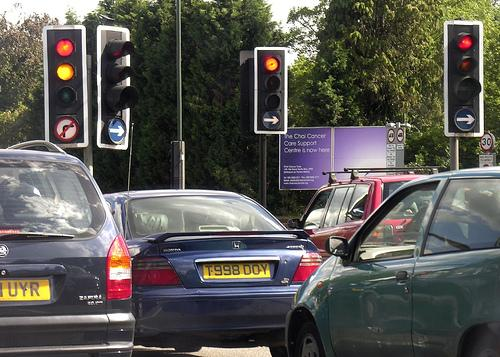Identify three types of signs in the image and describe their appearance. 3. No right turn sign List the colors of the different objects in the image. Red, yellow, blue, white, black, silver, green, orangered, purple What types of trees can you see in the image and what is their condition? Tree branches with green leafs and tall trees near a street intersection, both in a healthy condition. What color is the license plate on the blue car and what might it be made of? The license plate is yellow with black letters and may likely be made of metal or plastic. Describe the condition of the traffic light in the image. The traffic light shows red and yellow lights lit, indicating that vehicles should stop and be prepared for a change in traffic signals. In one sentence, what significant event is happening in the image? Four vehicles are waiting at a traffic intersection with red and yellow traffic lights. Which object in the image is related to supporting cancer patients? A purple sign for a cancer support center with white writing. What key features can you observe on the rear end of the blue car? A yellow license plate with black letters, tail light with orangered and white glass, and silver logo. What are the two main types of objects visible in this scene? Vehicles and traffic signals Is the front side of a green truck visible at X:326 Y:175 Width:89 Height:89? The instruction refers to a nonexistent object in the image, as there is no front side of a green truck in the given coordinates. Can you locate a white speed limit sign at X:478 Y:130 Width:20 Height:20, indicating the speed limit is 50 mph? The instruction is misleading as there is a speed limit sign at these coordinates, but it is not specified what speed is indicated on it. Is there a traffic light with a green arrow pointing upwards at X:254 Y:45 Width:34 Height:34? The instruction is misleading because the traffic light at the given coordinates has an arrow pointing right, not upwards, and there is no mention of the color green. Find a blue stop sign at X:242 Y:42 Width:52 Height:52 with illegible text on it. The instruction is misleading as the object at the given coordinates is a stop light with a red light lit, not a blue stop sign. Is there a rectangular traffic sign with a blue background and white lettering, instructing to turn left, at X:276 Y:122 Width:132 Height:132? This instruction is misleading because the object at the given coordinates is a blue street sign with white letters, but there is no mention of its message or shape in the original information. Do you see a group of flowering plants with colorful blooms at X:292 Y:1 Width:150 Height:150? The instruction is misleading as the object at the given coordinates is a group of trees, not flowering plants with colorful blooms. Observe an orange-tinged tail light with a cracked glass at X:100 Y:237 Width:41 Height:41. No, it's not mentioned in the image. Can you identify a purple sign with green writing at X:276 Y:113 Width:123 Height:123, which displays information about a recycling center? The instruction is misleading as the object at the given coordinates is a purple sign with white writing for a cancer support center, not a recycling center. Locate a bicycle with a silver logo on its frame at X:277 Y:234 Width:41 Height:41. This instruction is misleading, as there is no bicycle mentioned in the original information. The object at the given coordinates is a silver logo on the back of a car. Spot a yellow car with a red license plate at X:196 Y:256 Width:77 Height:77. The instruction is misleading as the object at the given coordinates is a yellow license plate with black writing, not a yellow car with a red license plate. 